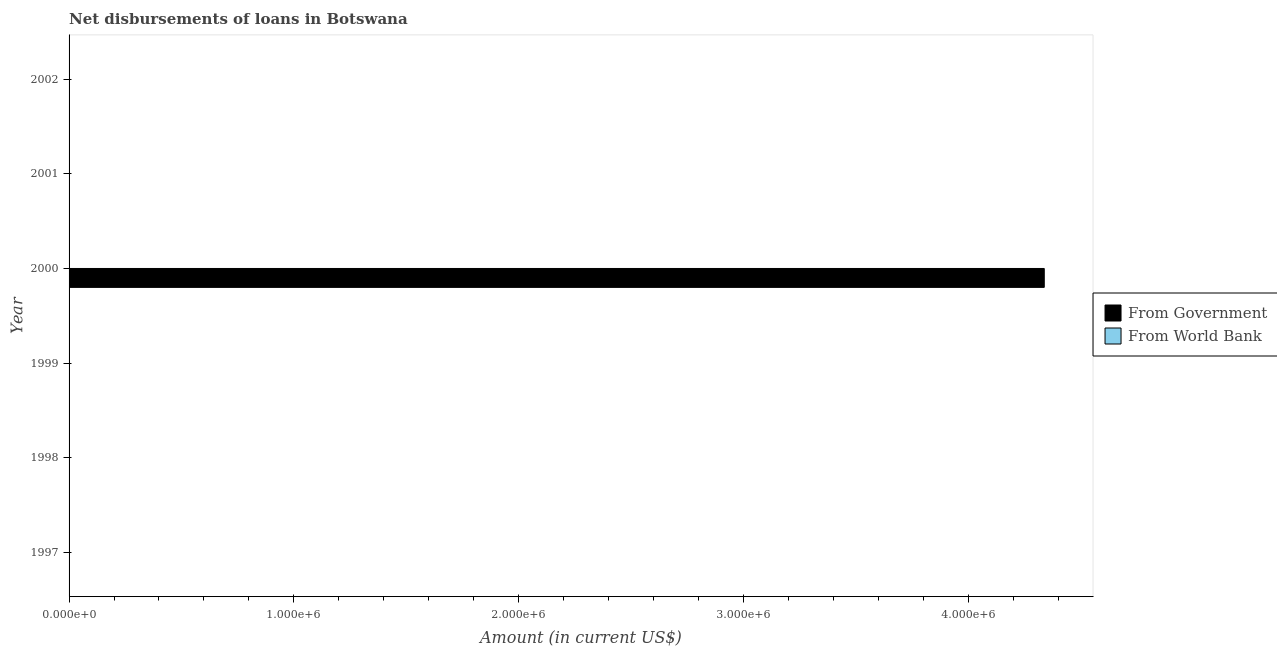Are the number of bars per tick equal to the number of legend labels?
Your response must be concise. No. How many bars are there on the 1st tick from the top?
Provide a succinct answer. 0. How many bars are there on the 3rd tick from the bottom?
Provide a succinct answer. 0. In how many cases, is the number of bars for a given year not equal to the number of legend labels?
Make the answer very short. 6. Across all years, what is the maximum net disbursements of loan from government?
Provide a succinct answer. 4.34e+06. In which year was the net disbursements of loan from government maximum?
Offer a very short reply. 2000. What is the total net disbursements of loan from world bank in the graph?
Provide a succinct answer. 0. What is the average net disbursements of loan from government per year?
Your response must be concise. 7.23e+05. What is the difference between the highest and the lowest net disbursements of loan from government?
Make the answer very short. 4.34e+06. How many bars are there?
Offer a terse response. 1. Are all the bars in the graph horizontal?
Provide a succinct answer. Yes. Are the values on the major ticks of X-axis written in scientific E-notation?
Your answer should be compact. Yes. Where does the legend appear in the graph?
Your response must be concise. Center right. What is the title of the graph?
Give a very brief answer. Net disbursements of loans in Botswana. What is the Amount (in current US$) in From Government in 1998?
Keep it short and to the point. 0. What is the Amount (in current US$) in From World Bank in 1998?
Your answer should be compact. 0. What is the Amount (in current US$) of From Government in 1999?
Give a very brief answer. 0. What is the Amount (in current US$) of From Government in 2000?
Make the answer very short. 4.34e+06. What is the Amount (in current US$) in From World Bank in 2000?
Provide a short and direct response. 0. Across all years, what is the maximum Amount (in current US$) of From Government?
Your response must be concise. 4.34e+06. What is the total Amount (in current US$) in From Government in the graph?
Keep it short and to the point. 4.34e+06. What is the total Amount (in current US$) of From World Bank in the graph?
Your answer should be compact. 0. What is the average Amount (in current US$) of From Government per year?
Provide a succinct answer. 7.23e+05. What is the average Amount (in current US$) in From World Bank per year?
Give a very brief answer. 0. What is the difference between the highest and the lowest Amount (in current US$) in From Government?
Offer a terse response. 4.34e+06. 